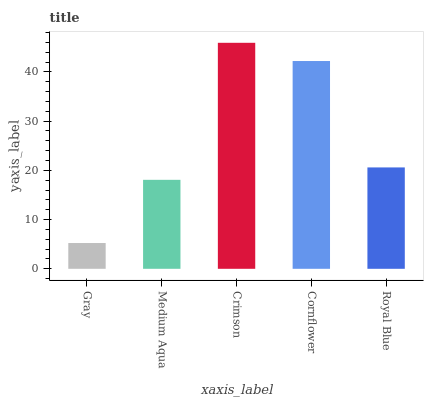Is Gray the minimum?
Answer yes or no. Yes. Is Crimson the maximum?
Answer yes or no. Yes. Is Medium Aqua the minimum?
Answer yes or no. No. Is Medium Aqua the maximum?
Answer yes or no. No. Is Medium Aqua greater than Gray?
Answer yes or no. Yes. Is Gray less than Medium Aqua?
Answer yes or no. Yes. Is Gray greater than Medium Aqua?
Answer yes or no. No. Is Medium Aqua less than Gray?
Answer yes or no. No. Is Royal Blue the high median?
Answer yes or no. Yes. Is Royal Blue the low median?
Answer yes or no. Yes. Is Cornflower the high median?
Answer yes or no. No. Is Cornflower the low median?
Answer yes or no. No. 